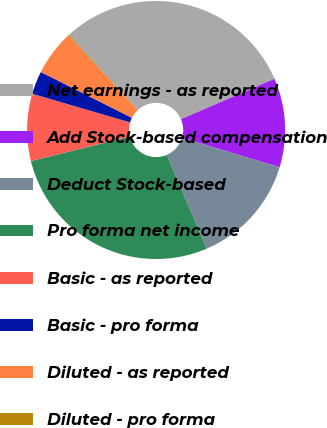Convert chart. <chart><loc_0><loc_0><loc_500><loc_500><pie_chart><fcel>Net earnings - as reported<fcel>Add Stock-based compensation<fcel>Deduct Stock-based<fcel>Pro forma net income<fcel>Basic - as reported<fcel>Basic - pro forma<fcel>Diluted - as reported<fcel>Diluted - pro forma<nl><fcel>30.3%<fcel>11.16%<fcel>13.91%<fcel>27.55%<fcel>8.4%<fcel>2.89%<fcel>5.65%<fcel>0.14%<nl></chart> 